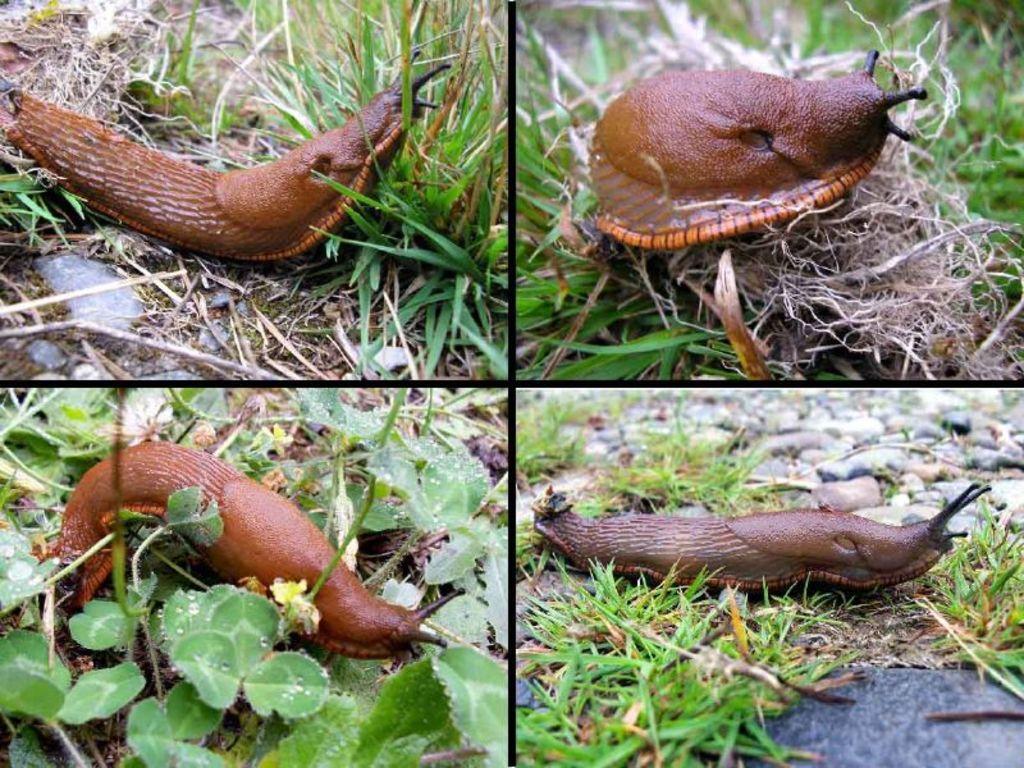Could you give a brief overview of what you see in this image? The picture is a collage of four images. In this picture there is slug in different positions. At the top left there is grass. At the top right there is dry grass and grass. At the bottom left there are plants. At the bottom right there are stones and grass. 